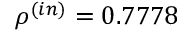<formula> <loc_0><loc_0><loc_500><loc_500>\rho ^ { ( i n ) } = 0 . 7 7 7 8</formula> 